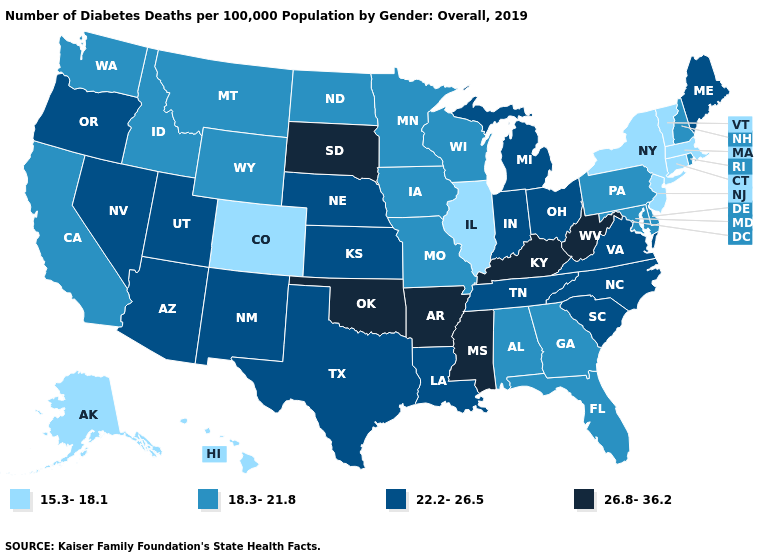Does the first symbol in the legend represent the smallest category?
Answer briefly. Yes. Name the states that have a value in the range 18.3-21.8?
Be succinct. Alabama, California, Delaware, Florida, Georgia, Idaho, Iowa, Maryland, Minnesota, Missouri, Montana, New Hampshire, North Dakota, Pennsylvania, Rhode Island, Washington, Wisconsin, Wyoming. What is the value of North Dakota?
Answer briefly. 18.3-21.8. What is the highest value in states that border New Hampshire?
Concise answer only. 22.2-26.5. What is the value of New Mexico?
Give a very brief answer. 22.2-26.5. Does the map have missing data?
Answer briefly. No. Name the states that have a value in the range 26.8-36.2?
Be succinct. Arkansas, Kentucky, Mississippi, Oklahoma, South Dakota, West Virginia. What is the value of Kansas?
Answer briefly. 22.2-26.5. Name the states that have a value in the range 22.2-26.5?
Answer briefly. Arizona, Indiana, Kansas, Louisiana, Maine, Michigan, Nebraska, Nevada, New Mexico, North Carolina, Ohio, Oregon, South Carolina, Tennessee, Texas, Utah, Virginia. What is the value of Hawaii?
Give a very brief answer. 15.3-18.1. Among the states that border New Hampshire , which have the highest value?
Short answer required. Maine. What is the highest value in the South ?
Short answer required. 26.8-36.2. What is the value of Kentucky?
Give a very brief answer. 26.8-36.2. Name the states that have a value in the range 15.3-18.1?
Short answer required. Alaska, Colorado, Connecticut, Hawaii, Illinois, Massachusetts, New Jersey, New York, Vermont. What is the lowest value in states that border Massachusetts?
Quick response, please. 15.3-18.1. 